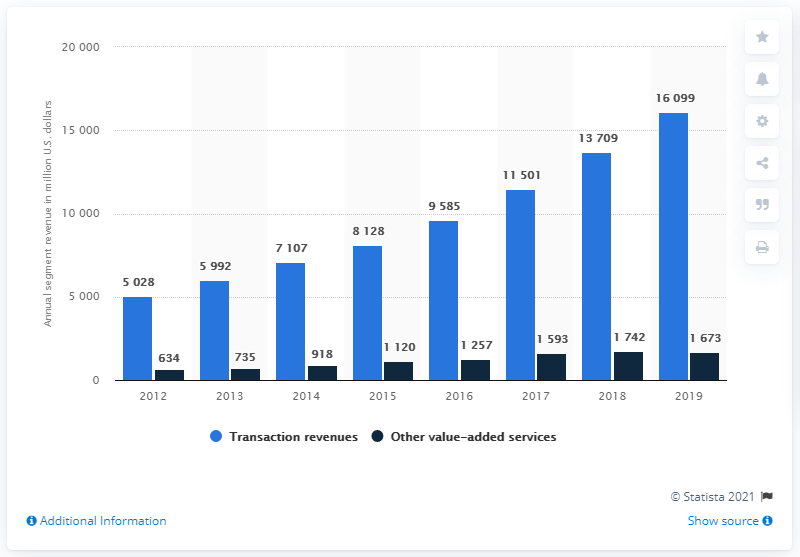Outline some significant characteristics in this image. In 2019, the value-added services other than our main service generated approximately 1673 dollars in revenue. PayPal's transaction revenues in 2019 were approximately $16,099. 